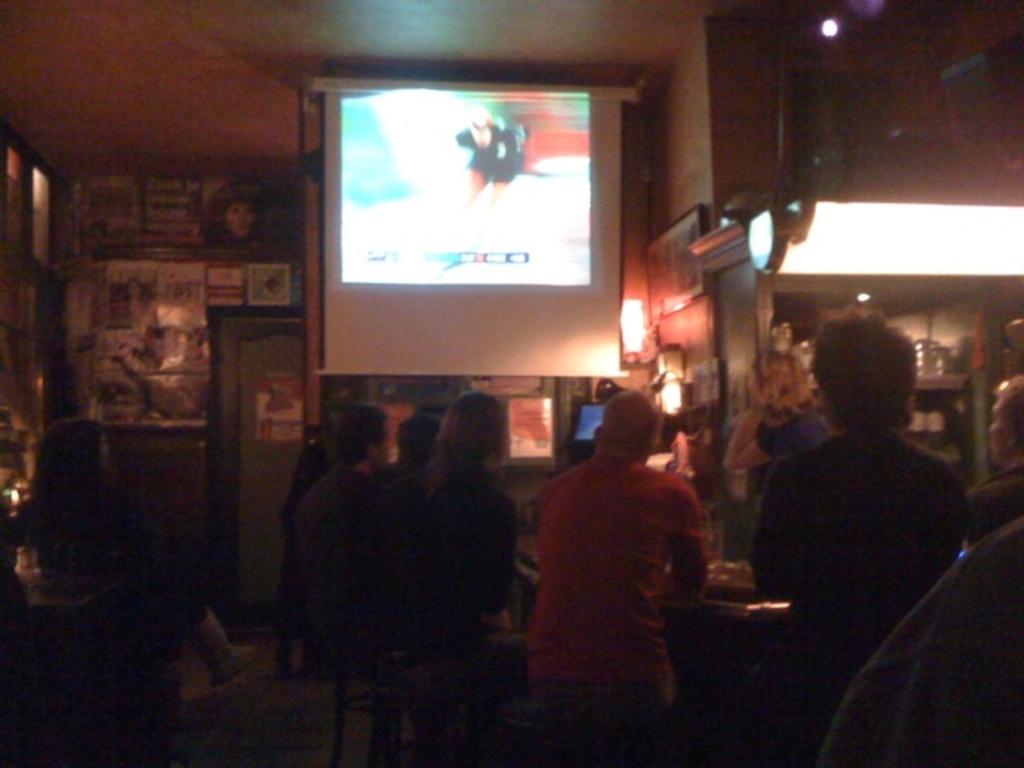Describe this image in one or two sentences. People are sitting on tables. This is screen. Here we can see light. Posters and board is on the wall. In this race there are objects.  